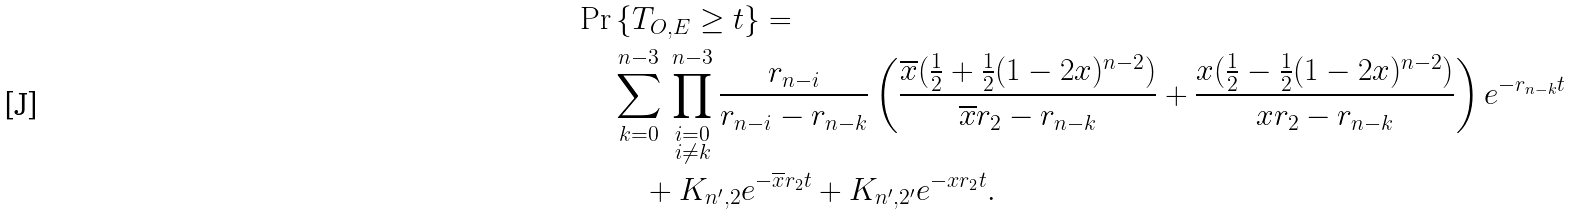Convert formula to latex. <formula><loc_0><loc_0><loc_500><loc_500>\Pr & \, \{ T _ { O , E } \geq t \} = \\ & \sum _ { k = 0 } ^ { n - 3 } \, \prod _ { \begin{subarray} { l } i = 0 \\ i \neq k \end{subarray} } ^ { n - 3 } \frac { r _ { n - i } } { r _ { n - i } - r _ { n - k } } \left ( \frac { \overline { x } ( \frac { 1 } { 2 } + \frac { 1 } { 2 } ( 1 - 2 x ) ^ { n - 2 } ) } { \overline { x } r _ { 2 } - r _ { n - k } } + \frac { x ( \frac { 1 } { 2 } - \frac { 1 } { 2 } ( 1 - 2 x ) ^ { n - 2 } ) } { x r _ { 2 } - r _ { n - k } } \right ) e ^ { - r _ { n - k } t } \\ & \quad + K _ { n ^ { \prime } , 2 } e ^ { - \overline { x } r _ { 2 } t } + K _ { n ^ { \prime } , 2 ^ { \prime } } e ^ { - x r _ { 2 } t } .</formula> 